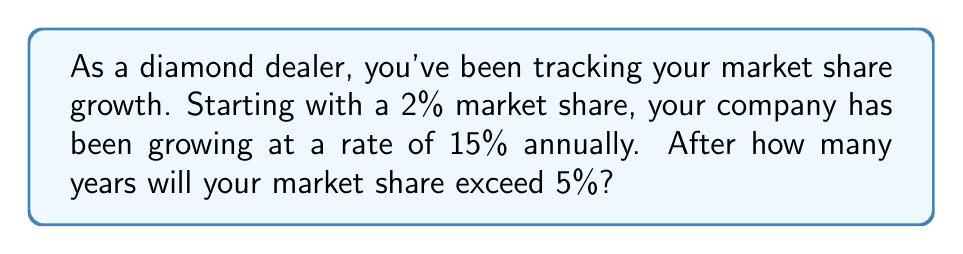Help me with this question. Let's approach this step-by-step:

1) We start with an initial market share of 2% and want to find when it exceeds 5%.

2) The annual growth rate is 15% or 0.15.

3) We can model this growth using the compound interest formula:

   $A = P(1 + r)^t$

   Where:
   $A$ = final amount
   $P$ = initial amount (2% or 0.02)
   $r$ = growth rate (15% or 0.15)
   $t$ = time in years

4) We want to find $t$ when $A > 0.05$ (5%):

   $0.05 > 0.02(1 + 0.15)^t$

5) Dividing both sides by 0.02:

   $2.5 > (1.15)^t$

6) Taking the natural log of both sides:

   $\ln(2.5) > t \cdot \ln(1.15)$

7) Solving for $t$:

   $t > \frac{\ln(2.5)}{\ln(1.15)} \approx 6.14$

8) Since we need a whole number of years and want to exceed 5%, we round up to 7 years.
Answer: It will take 7 years for the market share to exceed 5%. 